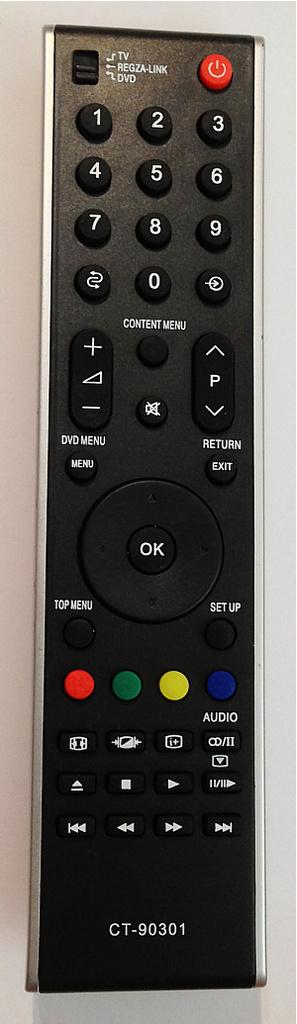<image>
Describe the image concisely. A television remote with the code CT-90301 written on the bottom. 